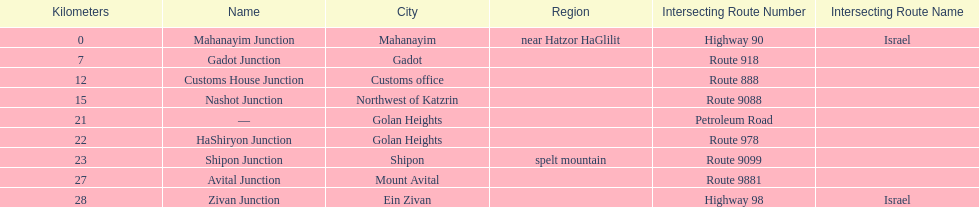What is the number of routes that intersect highway 91? 9. 